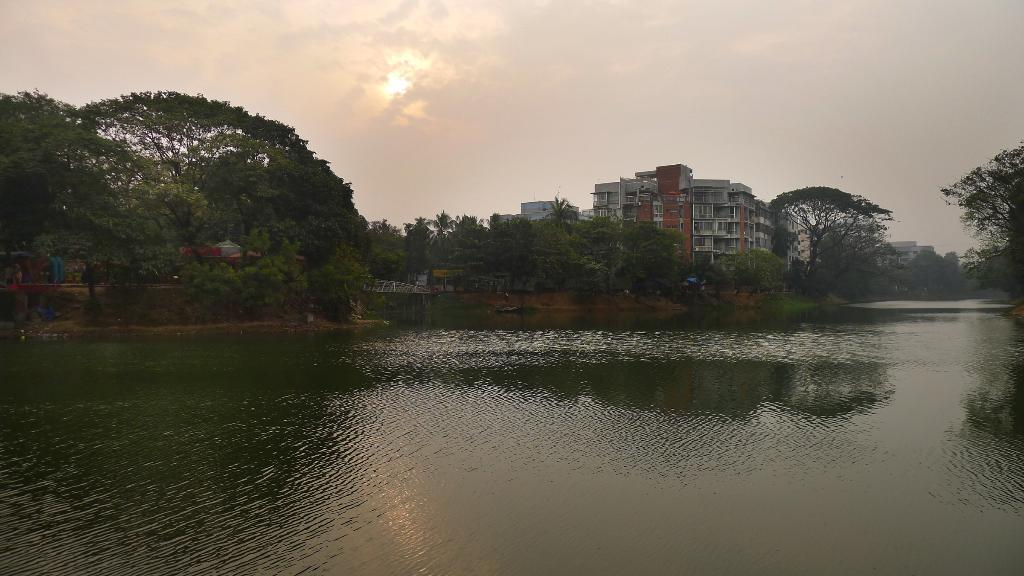What is the primary element present in the image? There is water in the image. What type of vegetation can be seen in the image? There are green trees in the image. Are there any man-made structures visible in the image? Yes, there are buildings in the image. What can be seen in the background of the image? The sky is visible in the background of the image. Is there any celestial body observable in the sky? Yes, the sun is observable in the sky. How many boats are present in the image? There are no boats visible in the image. Where is the queen sitting in the image? There is no queen present in the image. 